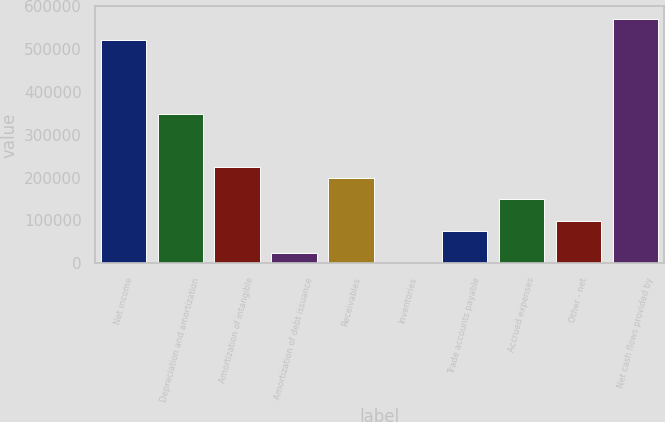Convert chart to OTSL. <chart><loc_0><loc_0><loc_500><loc_500><bar_chart><fcel>Net income<fcel>Depreciation and amortization<fcel>Amortization of intangible<fcel>Amortization of debt issuance<fcel>Receivables<fcel>Inventories<fcel>Trade accounts payable<fcel>Accrued expenses<fcel>Other - net<fcel>Net cash flows provided by<nl><fcel>521842<fcel>347958<fcel>223756<fcel>25031.5<fcel>198915<fcel>191<fcel>74712.5<fcel>149234<fcel>99553<fcel>571522<nl></chart> 